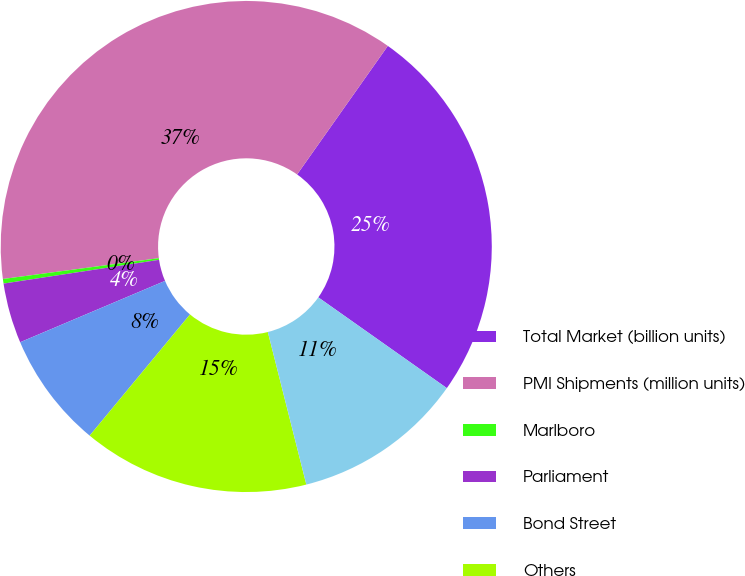Convert chart. <chart><loc_0><loc_0><loc_500><loc_500><pie_chart><fcel>Total Market (billion units)<fcel>PMI Shipments (million units)<fcel>Marlboro<fcel>Parliament<fcel>Bond Street<fcel>Others<fcel>Total<nl><fcel>25.0%<fcel>36.89%<fcel>0.3%<fcel>3.96%<fcel>7.62%<fcel>14.94%<fcel>11.28%<nl></chart> 